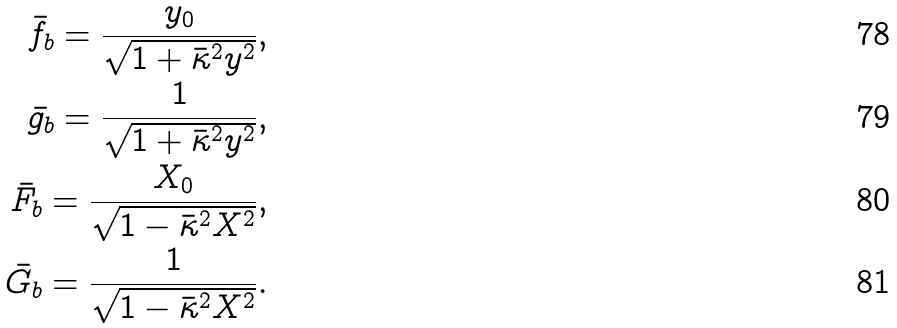Convert formula to latex. <formula><loc_0><loc_0><loc_500><loc_500>\bar { f _ { b } } = \frac { y _ { 0 } } { \sqrt { 1 + \bar { \kappa } ^ { 2 } y ^ { 2 } } } , \\ \bar { g _ { b } } = \frac { 1 } { \sqrt { 1 + \bar { \kappa } ^ { 2 } y ^ { 2 } } } , \\ \bar { F _ { b } } = \frac { X _ { 0 } } { \sqrt { 1 - \bar { \kappa } ^ { 2 } X ^ { 2 } } } , \\ \bar { G _ { b } } = \frac { 1 } { \sqrt { 1 - \bar { \kappa } ^ { 2 } X ^ { 2 } } } .</formula> 